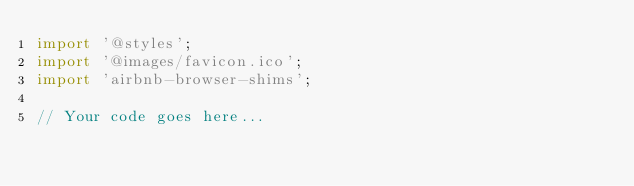<code> <loc_0><loc_0><loc_500><loc_500><_JavaScript_>import '@styles';
import '@images/favicon.ico';
import 'airbnb-browser-shims';

// Your code goes here...
</code> 